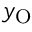Convert formula to latex. <formula><loc_0><loc_0><loc_500><loc_500>y _ { O }</formula> 